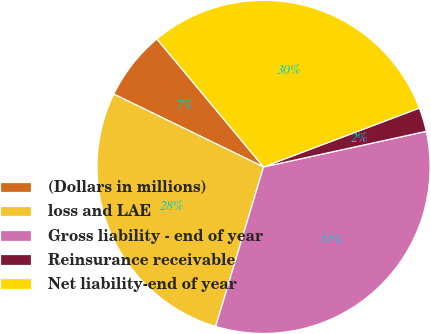Convert chart. <chart><loc_0><loc_0><loc_500><loc_500><pie_chart><fcel>(Dollars in millions)<fcel>loss and LAE<fcel>Gross liability - end of year<fcel>Reinsurance receivable<fcel>Net liability-end of year<nl><fcel>6.74%<fcel>27.56%<fcel>33.07%<fcel>2.32%<fcel>30.31%<nl></chart> 